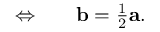<formula> <loc_0><loc_0><loc_500><loc_500>\begin{array} { r l } { \Leftrightarrow } & \quad b = \frac { 1 } { 2 } a . } \end{array}</formula> 